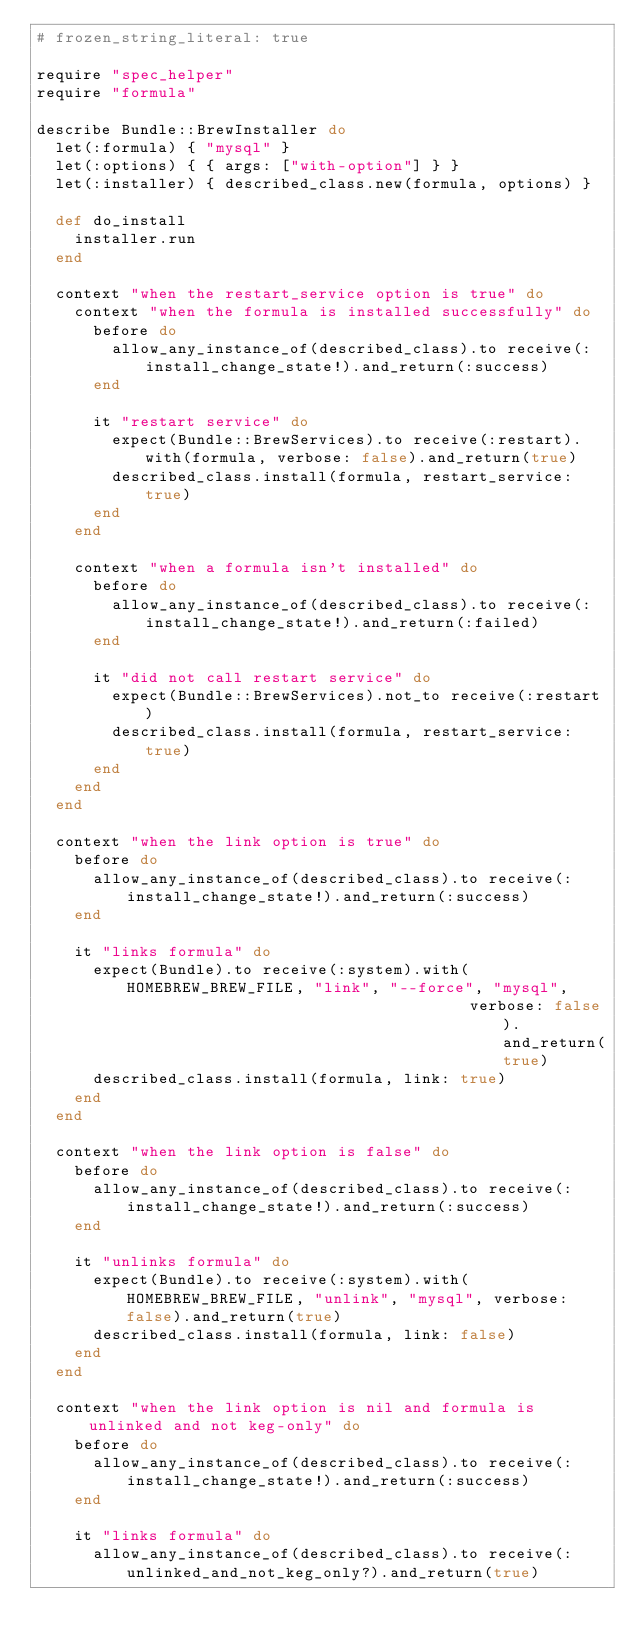Convert code to text. <code><loc_0><loc_0><loc_500><loc_500><_Ruby_># frozen_string_literal: true

require "spec_helper"
require "formula"

describe Bundle::BrewInstaller do
  let(:formula) { "mysql" }
  let(:options) { { args: ["with-option"] } }
  let(:installer) { described_class.new(formula, options) }

  def do_install
    installer.run
  end

  context "when the restart_service option is true" do
    context "when the formula is installed successfully" do
      before do
        allow_any_instance_of(described_class).to receive(:install_change_state!).and_return(:success)
      end

      it "restart service" do
        expect(Bundle::BrewServices).to receive(:restart).with(formula, verbose: false).and_return(true)
        described_class.install(formula, restart_service: true)
      end
    end

    context "when a formula isn't installed" do
      before do
        allow_any_instance_of(described_class).to receive(:install_change_state!).and_return(:failed)
      end

      it "did not call restart service" do
        expect(Bundle::BrewServices).not_to receive(:restart)
        described_class.install(formula, restart_service: true)
      end
    end
  end

  context "when the link option is true" do
    before do
      allow_any_instance_of(described_class).to receive(:install_change_state!).and_return(:success)
    end

    it "links formula" do
      expect(Bundle).to receive(:system).with(HOMEBREW_BREW_FILE, "link", "--force", "mysql",
                                              verbose: false).and_return(true)
      described_class.install(formula, link: true)
    end
  end

  context "when the link option is false" do
    before do
      allow_any_instance_of(described_class).to receive(:install_change_state!).and_return(:success)
    end

    it "unlinks formula" do
      expect(Bundle).to receive(:system).with(HOMEBREW_BREW_FILE, "unlink", "mysql", verbose: false).and_return(true)
      described_class.install(formula, link: false)
    end
  end

  context "when the link option is nil and formula is unlinked and not keg-only" do
    before do
      allow_any_instance_of(described_class).to receive(:install_change_state!).and_return(:success)
    end

    it "links formula" do
      allow_any_instance_of(described_class).to receive(:unlinked_and_not_keg_only?).and_return(true)</code> 